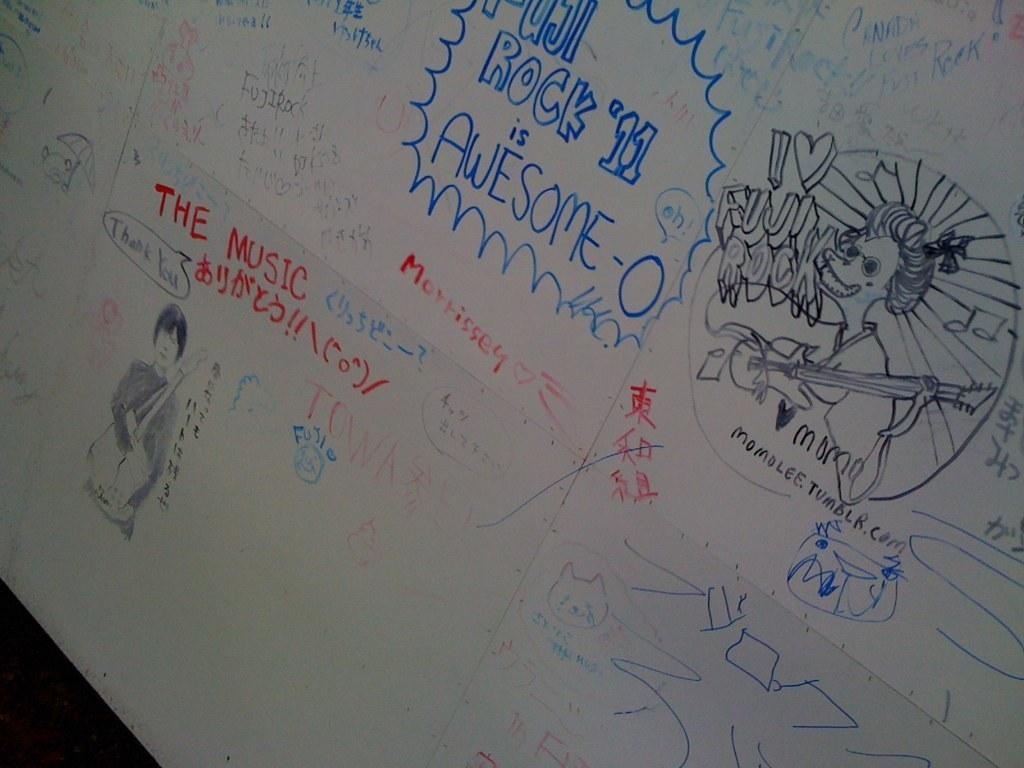<image>
Create a compact narrative representing the image presented. Drawings and writing on the white board with the message that Rock '11 is Awesome. 